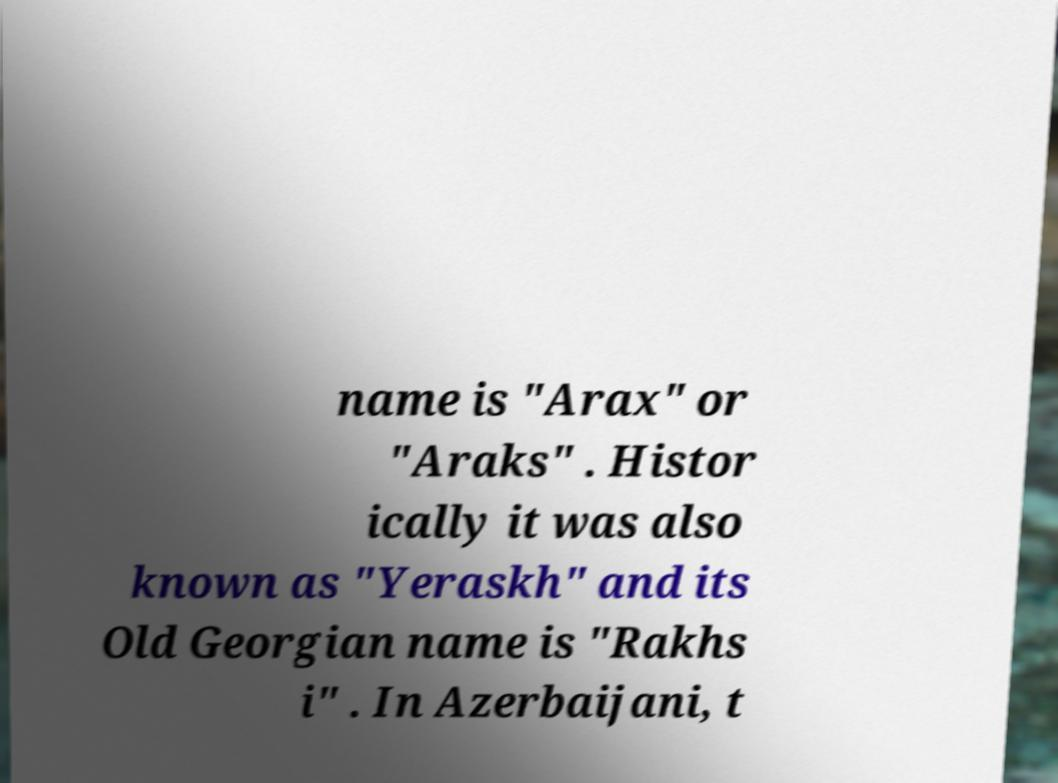I need the written content from this picture converted into text. Can you do that? name is "Arax" or "Araks" . Histor ically it was also known as "Yeraskh" and its Old Georgian name is "Rakhs i" . In Azerbaijani, t 